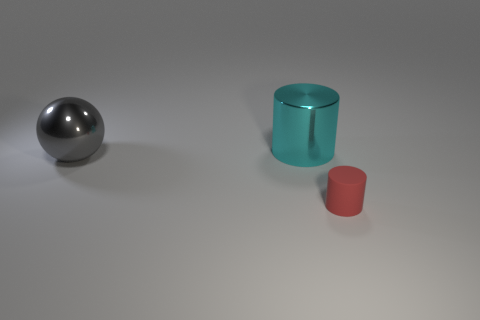The object that is in front of the big metallic thing in front of the big cyan object is what shape?
Offer a very short reply. Cylinder. Are there any large gray objects that have the same shape as the cyan object?
Your answer should be very brief. No. There is a large metallic ball; does it have the same color as the shiny object that is behind the large metal sphere?
Keep it short and to the point. No. Is there another metal cylinder of the same size as the cyan cylinder?
Provide a succinct answer. No. Is the material of the red thing the same as the large thing to the left of the large metallic cylinder?
Your answer should be very brief. No. Are there more tiny rubber cylinders than large purple cylinders?
Ensure brevity in your answer.  Yes. How many spheres are gray matte things or gray metallic things?
Ensure brevity in your answer.  1. The metal sphere is what color?
Ensure brevity in your answer.  Gray. There is a cylinder in front of the large shiny ball; does it have the same size as the cylinder behind the small matte cylinder?
Your answer should be very brief. No. Is the number of brown metal cubes less than the number of gray things?
Ensure brevity in your answer.  Yes. 